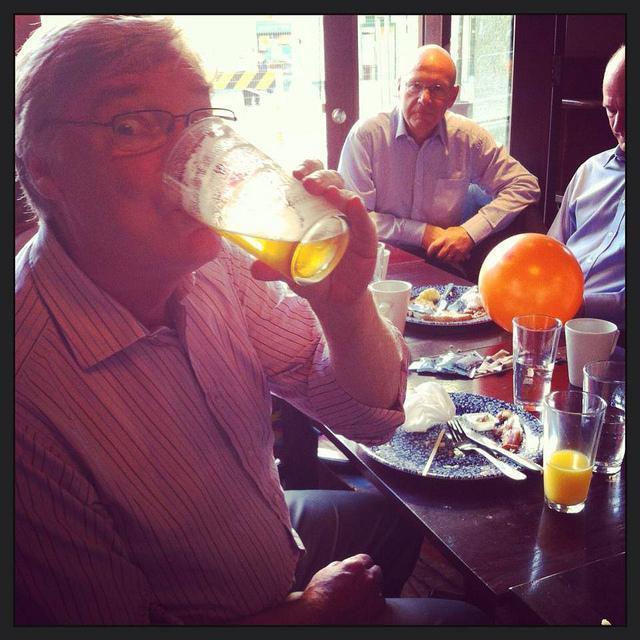How many people are visible?
Give a very brief answer. 3. How many cups are there?
Give a very brief answer. 5. 